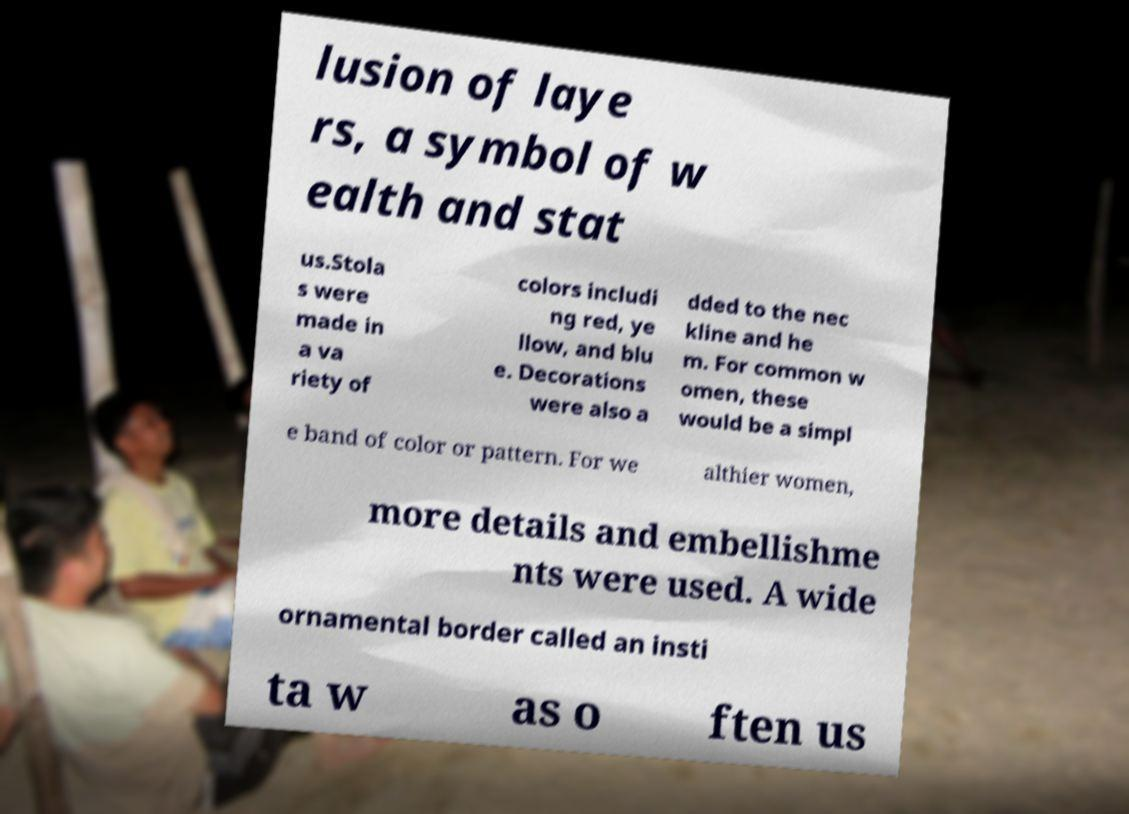Could you assist in decoding the text presented in this image and type it out clearly? lusion of laye rs, a symbol of w ealth and stat us.Stola s were made in a va riety of colors includi ng red, ye llow, and blu e. Decorations were also a dded to the nec kline and he m. For common w omen, these would be a simpl e band of color or pattern. For we althier women, more details and embellishme nts were used. A wide ornamental border called an insti ta w as o ften us 